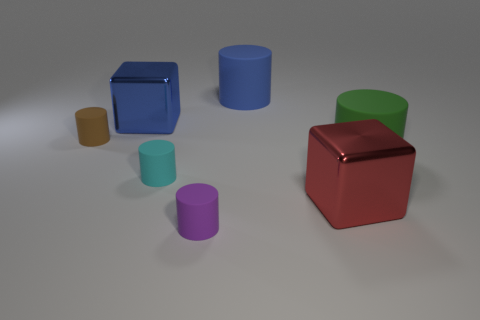How many rubber things are right of the brown rubber object and left of the green rubber cylinder?
Give a very brief answer. 3. There is a blue object that is right of the tiny purple matte thing; what is its shape?
Provide a short and direct response. Cylinder. Is the number of small purple objects on the left side of the purple rubber object less than the number of big blue cylinders left of the big red metallic cube?
Provide a succinct answer. Yes. Is the blue thing that is to the right of the blue shiny cube made of the same material as the cylinder on the left side of the blue shiny cube?
Provide a succinct answer. Yes. What is the shape of the big red thing?
Ensure brevity in your answer.  Cube. Are there more tiny purple rubber things that are on the left side of the small purple matte cylinder than brown cylinders that are behind the brown object?
Ensure brevity in your answer.  No. Is the shape of the small rubber thing that is in front of the small cyan matte object the same as the big rubber object to the left of the red shiny cube?
Your response must be concise. Yes. What number of other things are the same size as the brown matte cylinder?
Your response must be concise. 2. The brown cylinder is what size?
Keep it short and to the point. Small. Are the large cube on the left side of the tiny purple rubber cylinder and the cyan cylinder made of the same material?
Make the answer very short. No. 